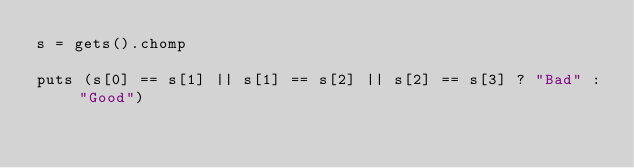Convert code to text. <code><loc_0><loc_0><loc_500><loc_500><_Ruby_>s = gets().chomp

puts (s[0] == s[1] || s[1] == s[2] || s[2] == s[3] ? "Bad" : "Good")
</code> 